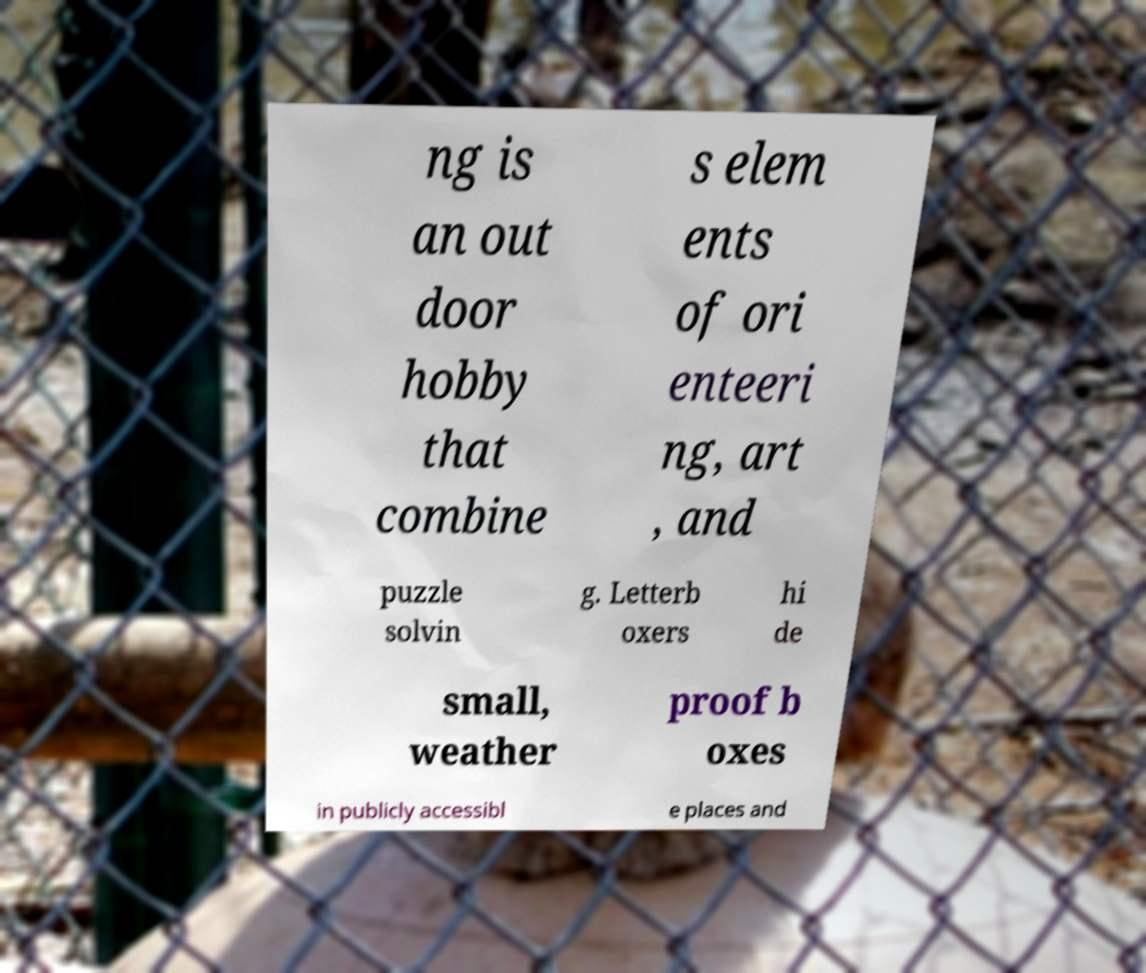I need the written content from this picture converted into text. Can you do that? ng is an out door hobby that combine s elem ents of ori enteeri ng, art , and puzzle solvin g. Letterb oxers hi de small, weather proof b oxes in publicly accessibl e places and 